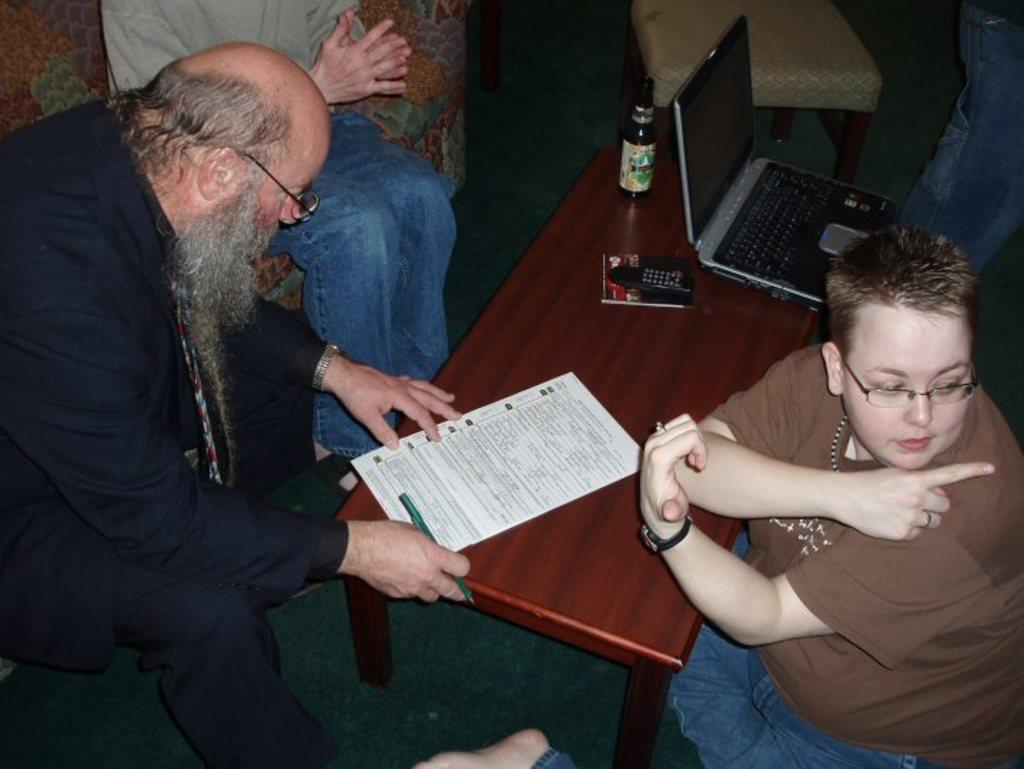How many people are sitting on the couch in the image? There are two people sitting on the couch in the image. Where is the third person sitting? The third person is sitting on the floor. What can be seen on the table in the image? There is a laptop and a paper on the table in the image. What might the people be using the laptop for? It is not clear from the image what the people are using the laptop for. What type of corn is being harvested in the yard in the image? There is no yard, corn, or harvesting activity present in the image. 